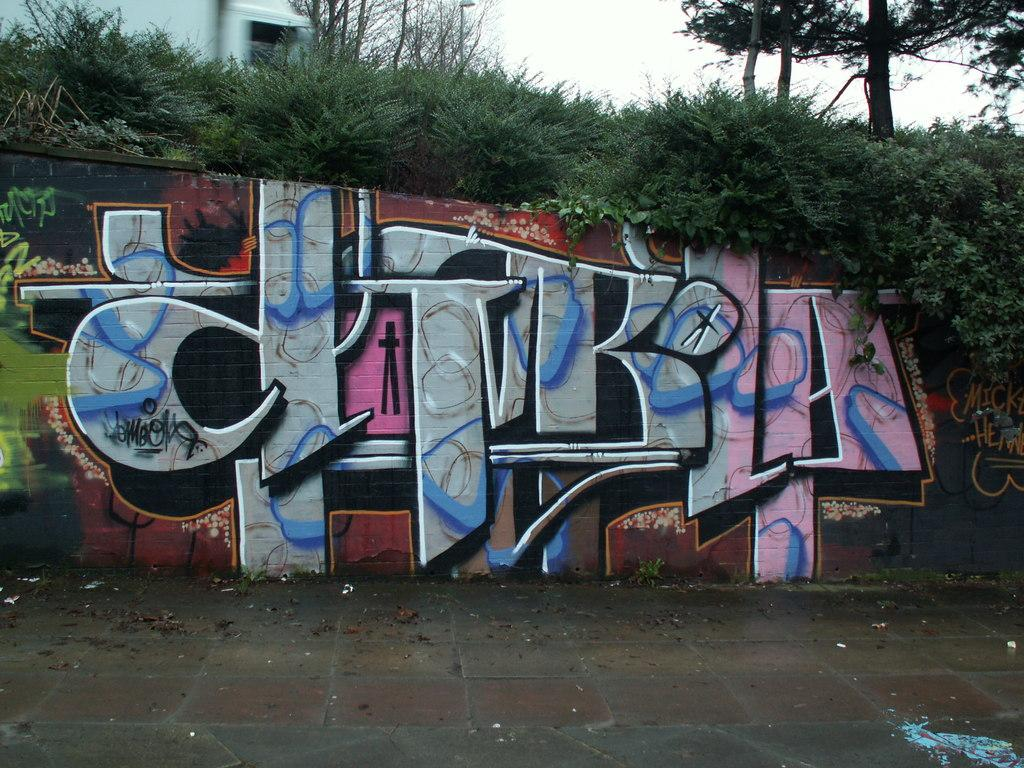What is present on the wall in the image? There is graffiti on the wall in the image. What can be seen in the background of the image? There are trees and the sky visible in the background of the image. What historical event is depicted in the graffiti on the wall? The provided facts do not mention any specific historical event depicted in the graffiti, so it cannot be determined from the image. 